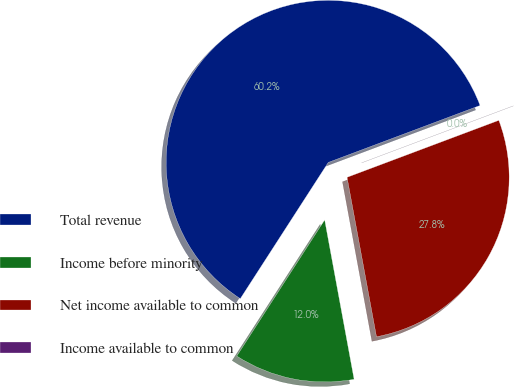Convert chart. <chart><loc_0><loc_0><loc_500><loc_500><pie_chart><fcel>Total revenue<fcel>Income before minority<fcel>Net income available to common<fcel>Income available to common<nl><fcel>60.16%<fcel>12.03%<fcel>27.81%<fcel>0.0%<nl></chart> 